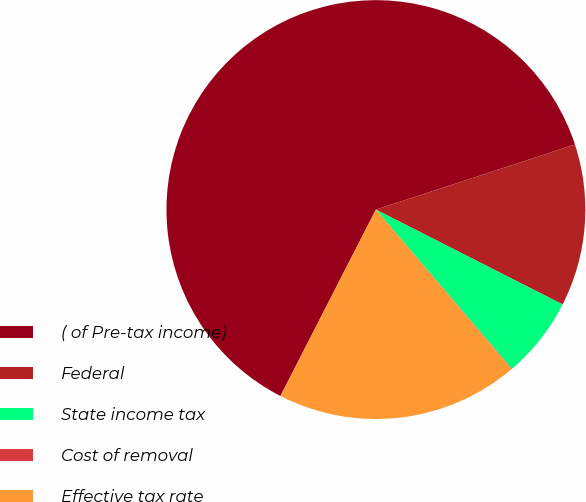<chart> <loc_0><loc_0><loc_500><loc_500><pie_chart><fcel>( of Pre-tax income)<fcel>Federal<fcel>State income tax<fcel>Cost of removal<fcel>Effective tax rate<nl><fcel>62.43%<fcel>12.51%<fcel>6.27%<fcel>0.03%<fcel>18.75%<nl></chart> 